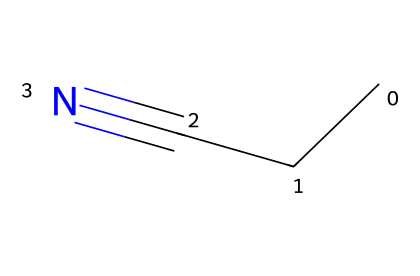What is the name of this chemical? The SMILES representation "CCC#N" corresponds to propionitrile, which is recognized by its linear structure consisting of three carbon atoms followed by a nitrogen atom bonded via a triple bond.
Answer: propionitrile How many carbon atoms are in propionitrile? The structure identified in the SMILES shows three 'C' characters, indicating there are three carbon atoms present in propionitrile.
Answer: three What type of bond exists between the last carbon and the nitrogen in propionitrile? The SMILES notation "CCC#N" features a '#' symbol, denoting a triple bond between the last carbon (C) and the nitrogen (N) atom.
Answer: triple bond What is the functional group in propionitrile? Propionitrile contains a nitrile functional group, characterized by the presence of the triple bond between carbon and nitrogen (the -C≡N part) noted in its structure.
Answer: nitrile How many hydrogen atoms are in propionitrile? To determine the number of hydrogen atoms, consider that three carbons (C) in propionitrile typically bond with hydrogen, leading to one carbon being fully connected to three hydrogens, while the other two carbons are connected to the previous one or to the nitrogen, resulting in a total of five hydrogen atoms.
Answer: five Why is propionitrile classified as a nitrile? Propionitrile is classified as a nitrile because it contains a carbon atom bonded to a nitrogen atom via a triple bond (the defining feature of nitrile compounds), which is evident in the structure's depiction.
Answer: because of the C≡N group What role does propionitrile play in diesel fuel additives? Propionitrile serves as a component in certain diesel fuel additives, improving the combustion characteristics and efficiency of the fuel.
Answer: improves combustion characteristics 